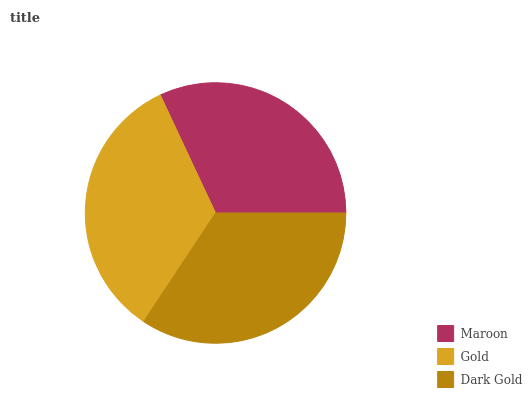Is Maroon the minimum?
Answer yes or no. Yes. Is Dark Gold the maximum?
Answer yes or no. Yes. Is Gold the minimum?
Answer yes or no. No. Is Gold the maximum?
Answer yes or no. No. Is Gold greater than Maroon?
Answer yes or no. Yes. Is Maroon less than Gold?
Answer yes or no. Yes. Is Maroon greater than Gold?
Answer yes or no. No. Is Gold less than Maroon?
Answer yes or no. No. Is Gold the high median?
Answer yes or no. Yes. Is Gold the low median?
Answer yes or no. Yes. Is Dark Gold the high median?
Answer yes or no. No. Is Dark Gold the low median?
Answer yes or no. No. 